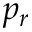<formula> <loc_0><loc_0><loc_500><loc_500>p _ { r }</formula> 